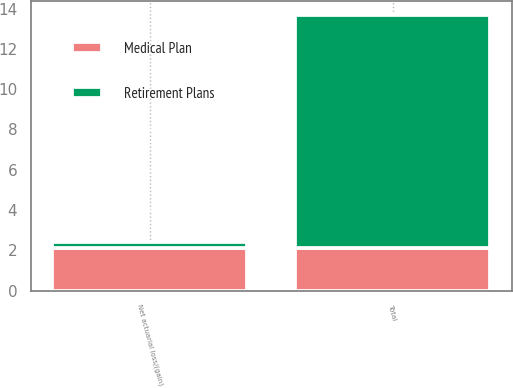Convert chart. <chart><loc_0><loc_0><loc_500><loc_500><stacked_bar_chart><ecel><fcel>Net actuarial loss/(gain)<fcel>Total<nl><fcel>Medical Plan<fcel>2.1<fcel>2.1<nl><fcel>Retirement Plans<fcel>0.3<fcel>11.6<nl></chart> 